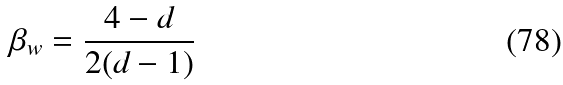Convert formula to latex. <formula><loc_0><loc_0><loc_500><loc_500>\beta _ { w } = \frac { 4 - d } { 2 ( d - 1 ) }</formula> 